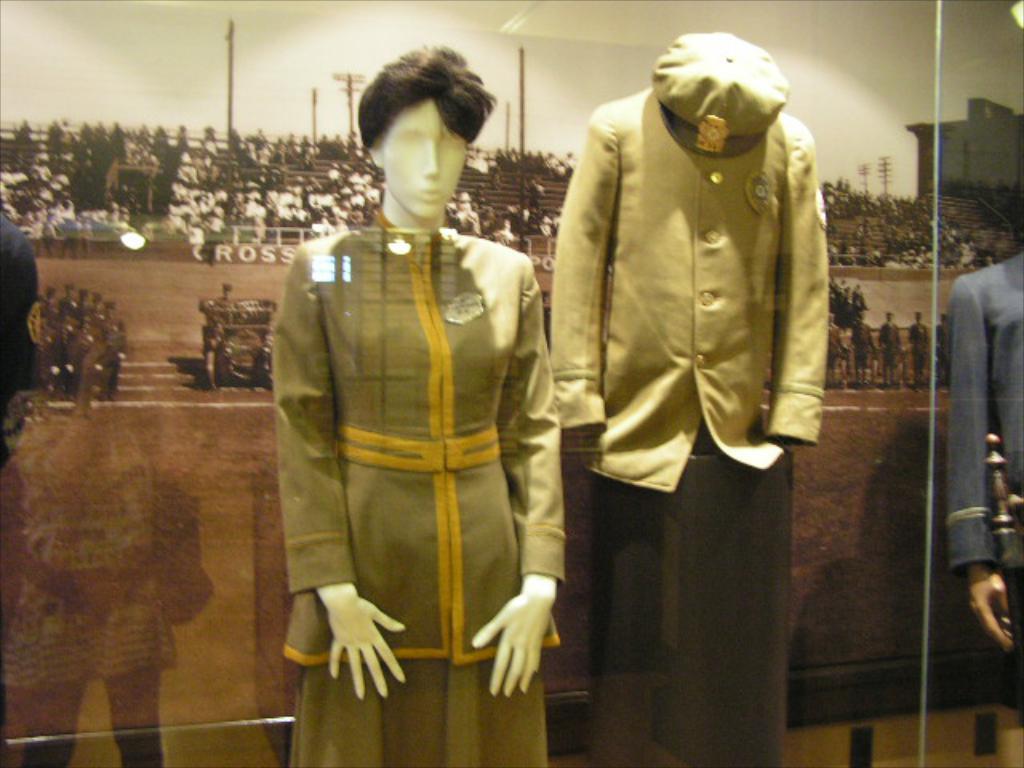Can you describe this image briefly? Here we can see mannequins with dress. Background there is a poster. On this poster we can see people and poles.  